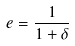Convert formula to latex. <formula><loc_0><loc_0><loc_500><loc_500>e = \frac { 1 } { 1 + \delta }</formula> 